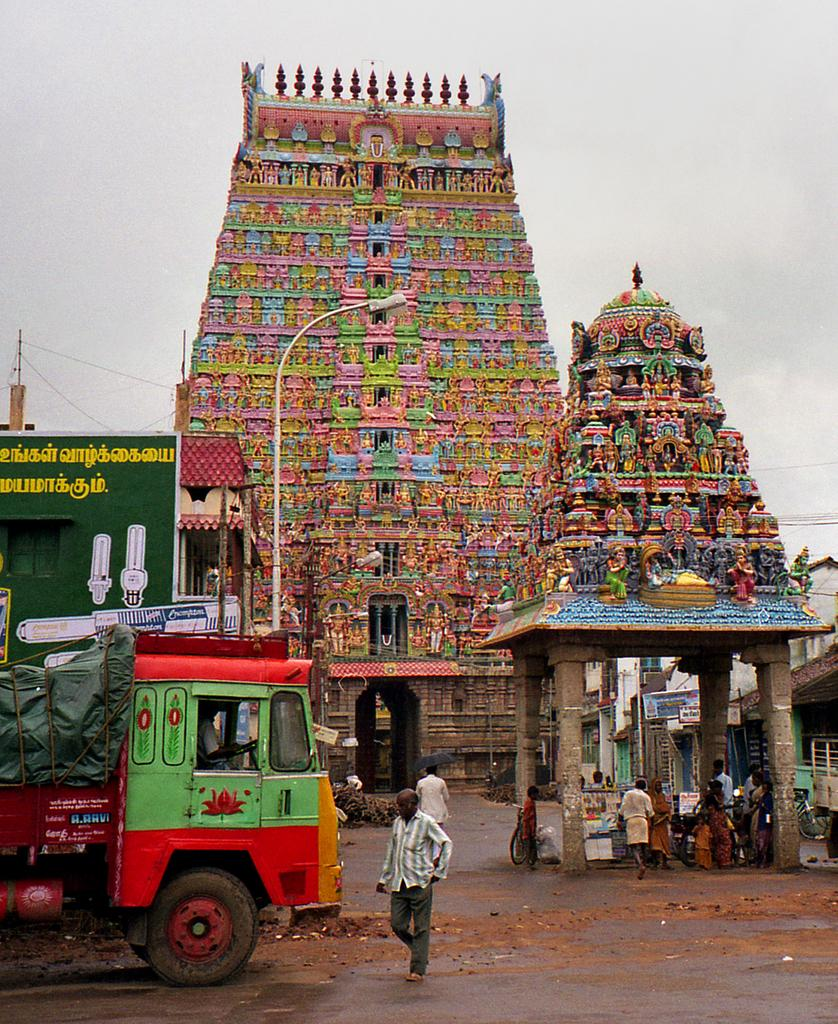What type of structure is the main subject of the image? There is a temple in the image. What other objects can be seen in the image? There is a pole, pillars, a gazebo, a vehicle, buildings, persons, and boards visible in the image. Can you describe the surroundings of the temple? The sky is visible in the background of the image. What type of bear can be seen standing on its hind legs near the temple in the image? There is no bear present in the image; it features a temple, a pole, pillars, a gazebo, a vehicle, buildings, persons, and boards. What is the chin of the person in the image doing? There is no chin visible in the image, as it is a photograph of a scene and does not focus on any individual person's features. 